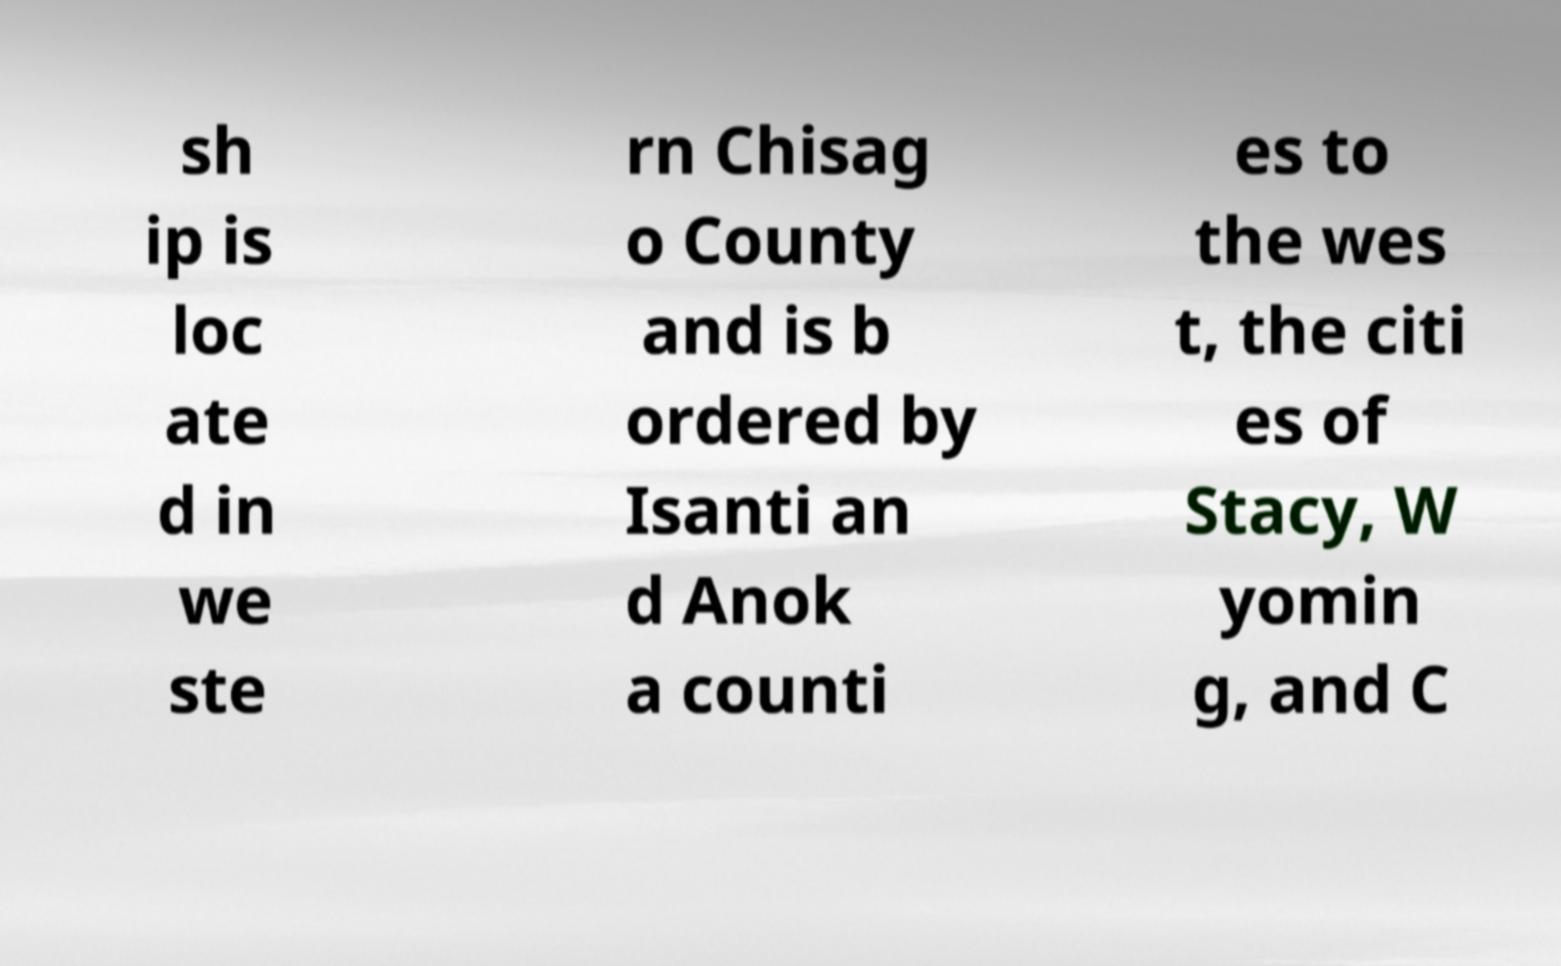For documentation purposes, I need the text within this image transcribed. Could you provide that? sh ip is loc ate d in we ste rn Chisag o County and is b ordered by Isanti an d Anok a counti es to the wes t, the citi es of Stacy, W yomin g, and C 